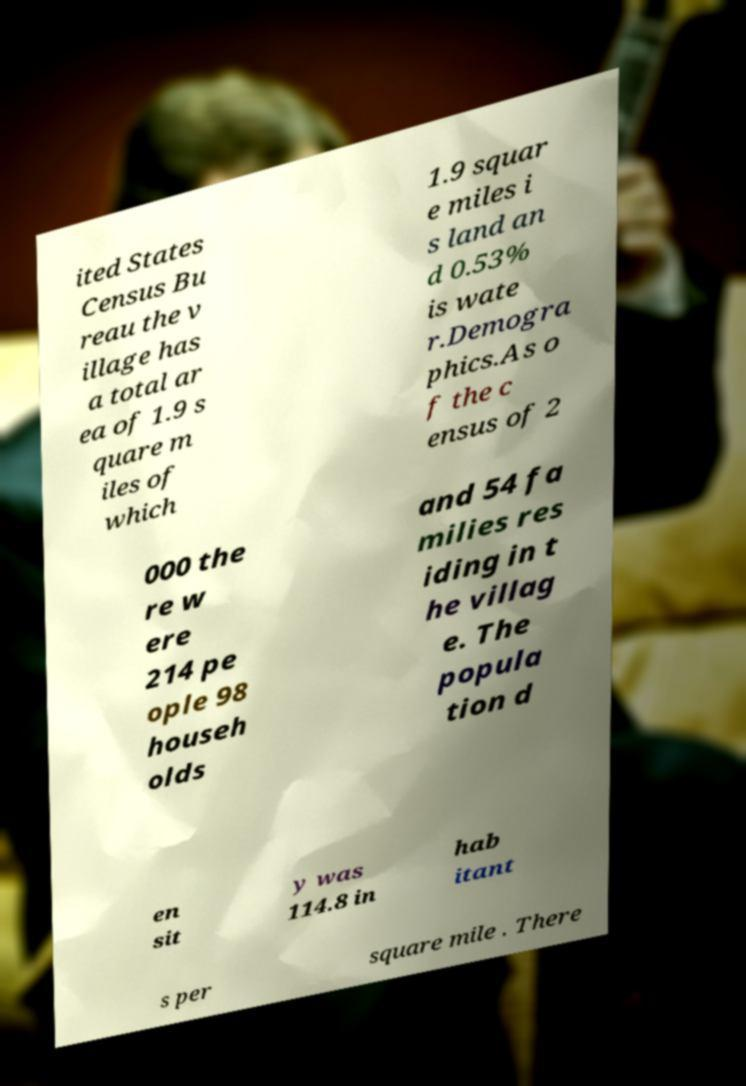There's text embedded in this image that I need extracted. Can you transcribe it verbatim? ited States Census Bu reau the v illage has a total ar ea of 1.9 s quare m iles of which 1.9 squar e miles i s land an d 0.53% is wate r.Demogra phics.As o f the c ensus of 2 000 the re w ere 214 pe ople 98 househ olds and 54 fa milies res iding in t he villag e. The popula tion d en sit y was 114.8 in hab itant s per square mile . There 